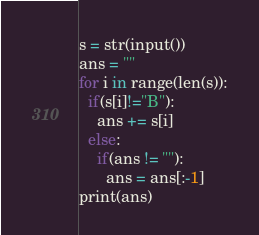Convert code to text. <code><loc_0><loc_0><loc_500><loc_500><_Python_>s = str(input())
ans = ""
for i in range(len(s)):
  if(s[i]!="B"):
    ans += s[i]
  else:
    if(ans != ""):
      ans = ans[:-1]
print(ans)

</code> 